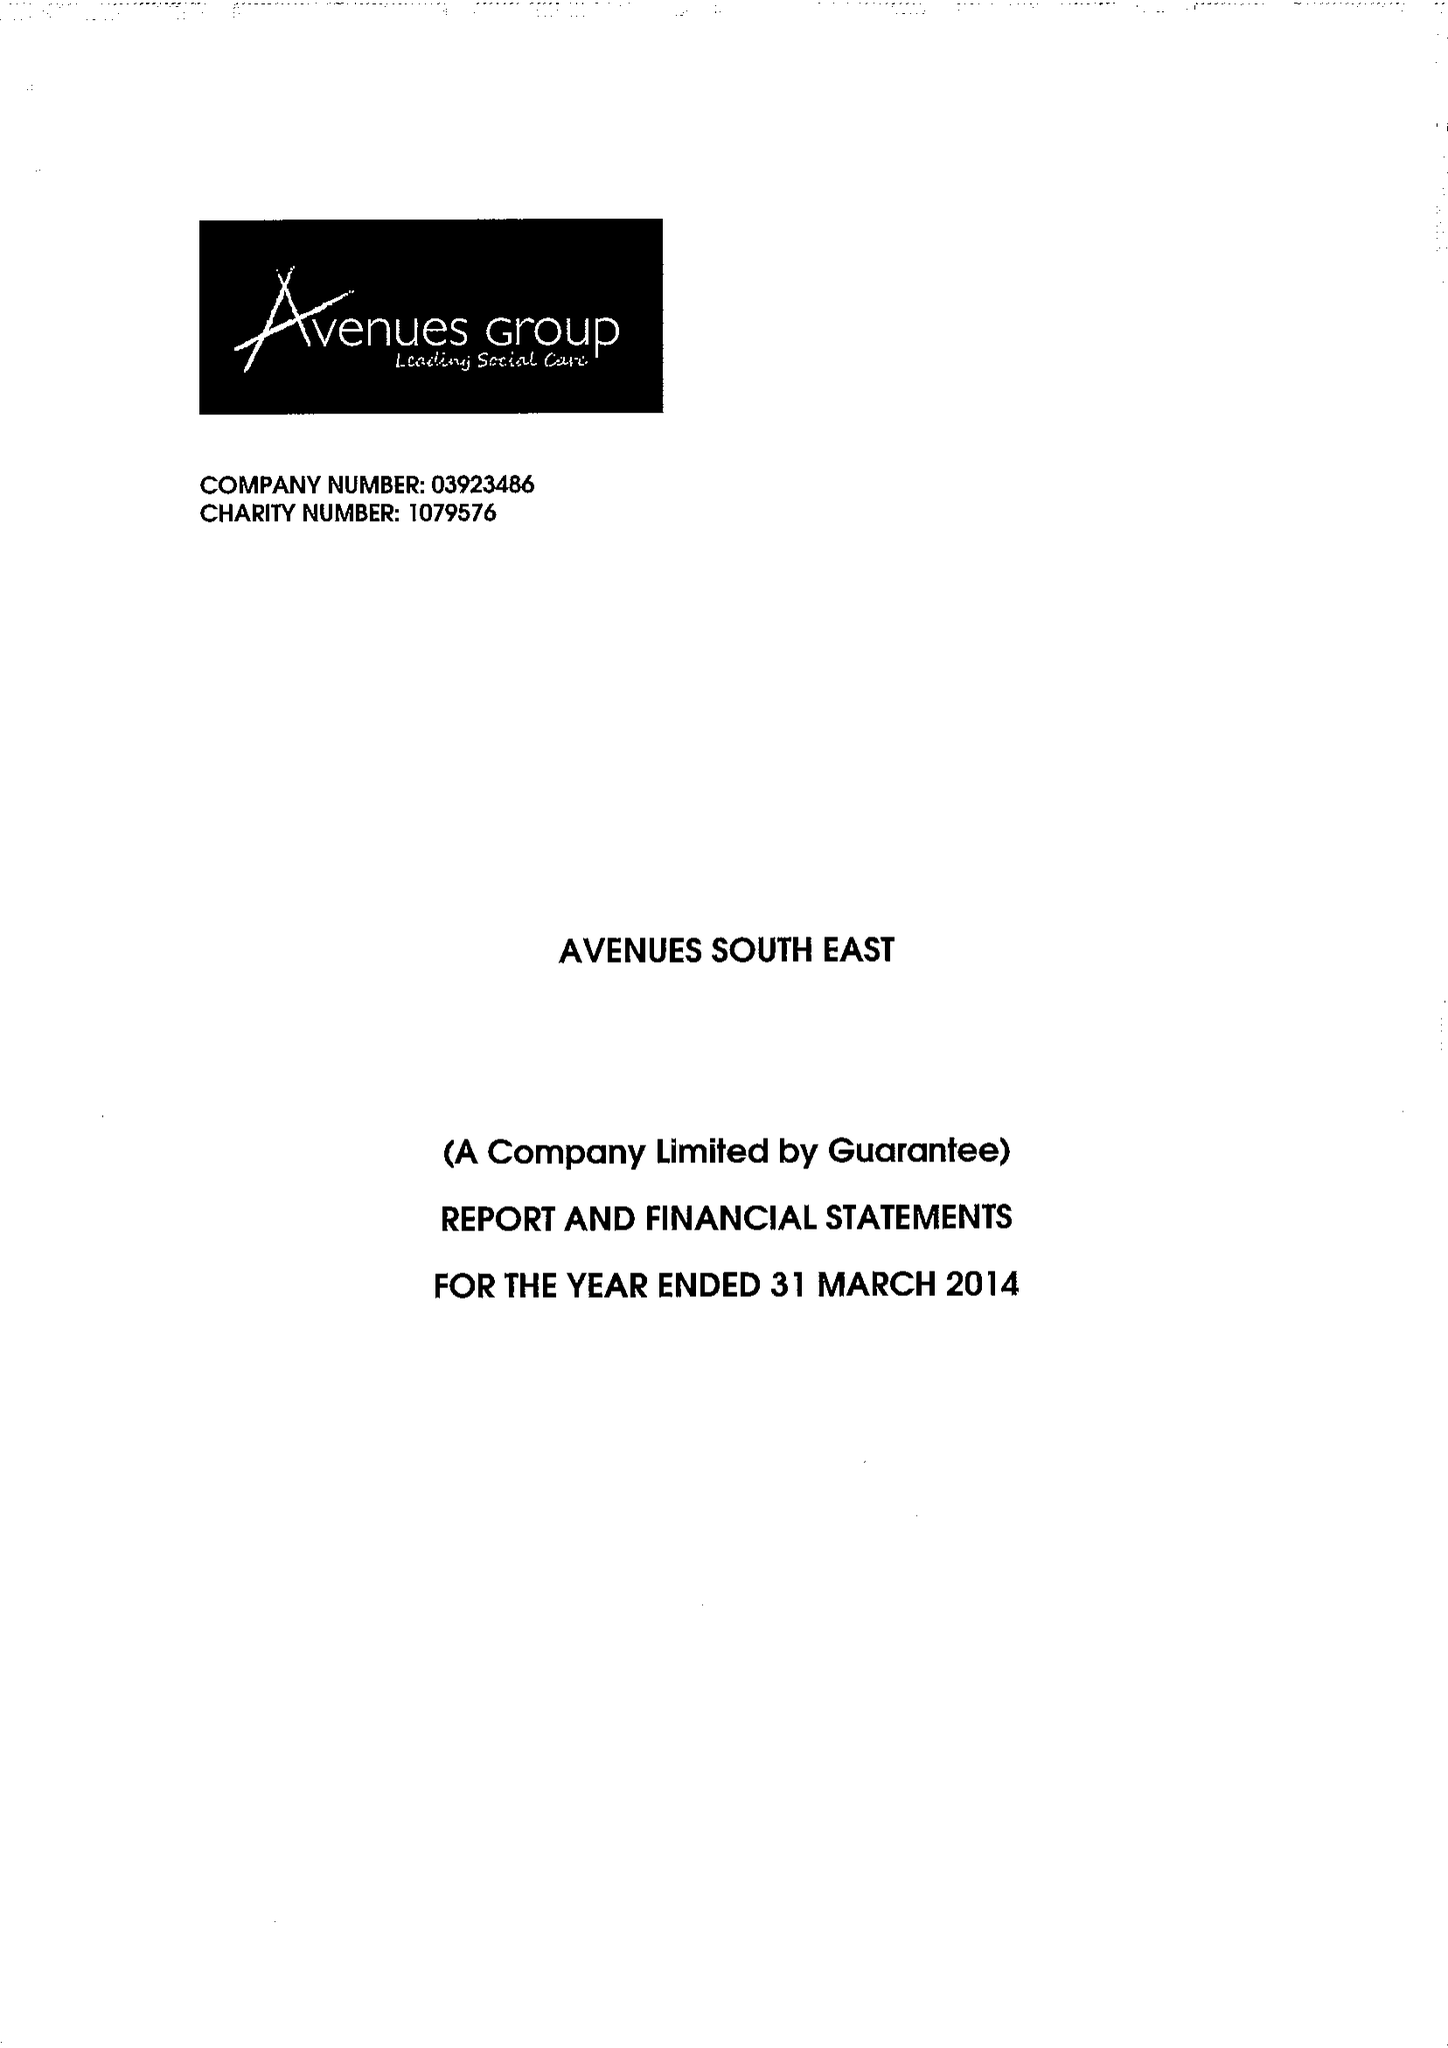What is the value for the charity_number?
Answer the question using a single word or phrase. 1079576 